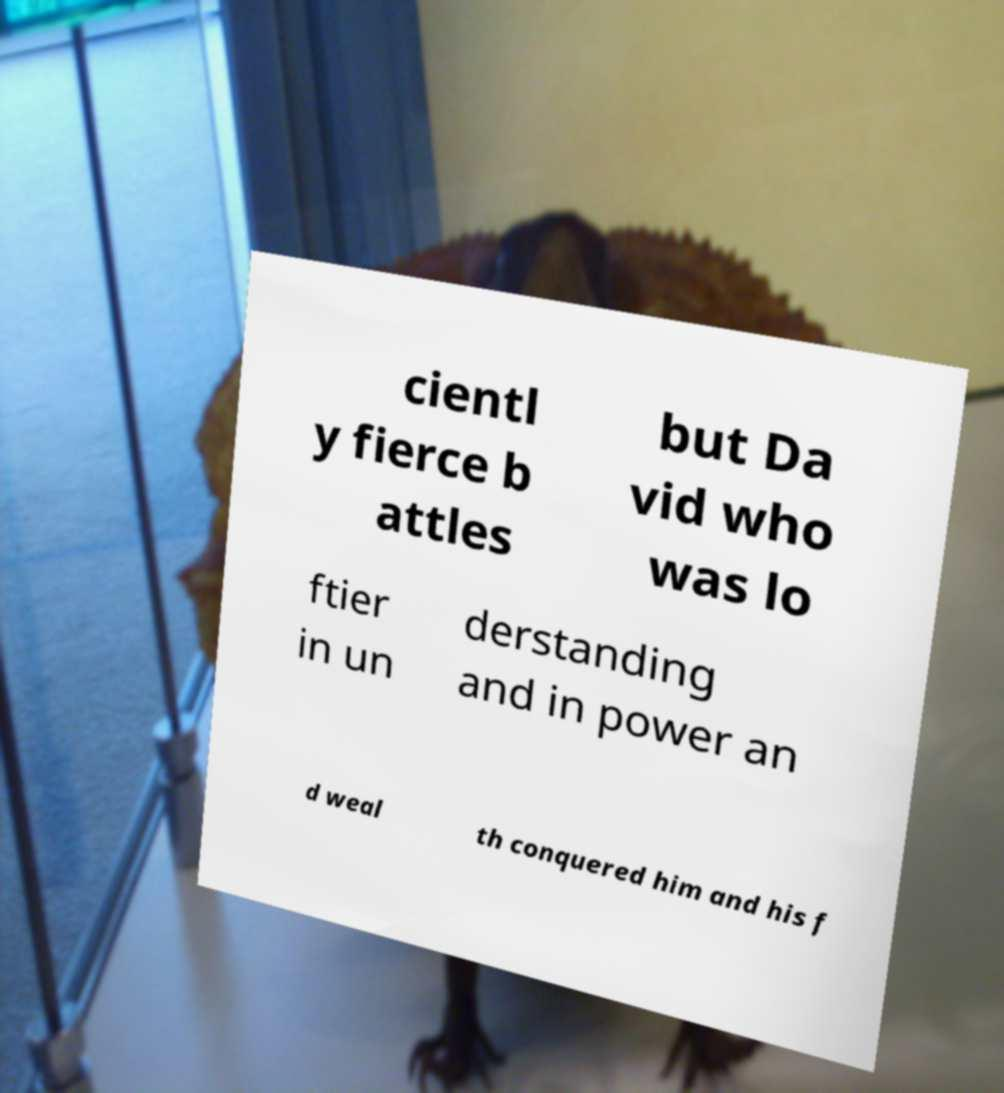Can you read and provide the text displayed in the image?This photo seems to have some interesting text. Can you extract and type it out for me? cientl y fierce b attles but Da vid who was lo ftier in un derstanding and in power an d weal th conquered him and his f 